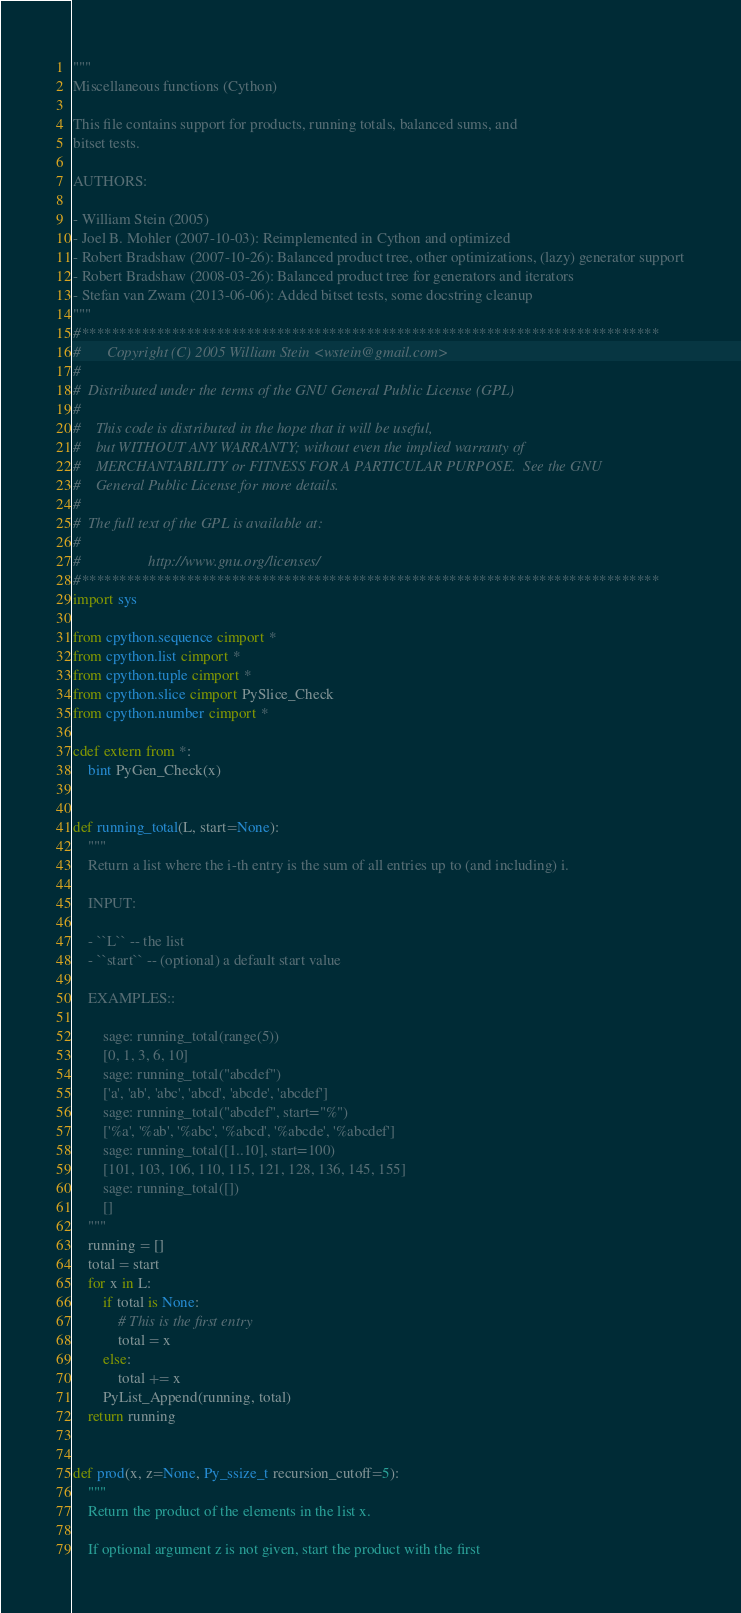Convert code to text. <code><loc_0><loc_0><loc_500><loc_500><_Cython_>"""
Miscellaneous functions (Cython)

This file contains support for products, running totals, balanced sums, and
bitset tests.

AUTHORS:

- William Stein (2005)
- Joel B. Mohler (2007-10-03): Reimplemented in Cython and optimized
- Robert Bradshaw (2007-10-26): Balanced product tree, other optimizations, (lazy) generator support
- Robert Bradshaw (2008-03-26): Balanced product tree for generators and iterators
- Stefan van Zwam (2013-06-06): Added bitset tests, some docstring cleanup
"""
#*****************************************************************************
#       Copyright (C) 2005 William Stein <wstein@gmail.com>
#
#  Distributed under the terms of the GNU General Public License (GPL)
#
#    This code is distributed in the hope that it will be useful,
#    but WITHOUT ANY WARRANTY; without even the implied warranty of
#    MERCHANTABILITY or FITNESS FOR A PARTICULAR PURPOSE.  See the GNU
#    General Public License for more details.
#
#  The full text of the GPL is available at:
#
#                  http://www.gnu.org/licenses/
#*****************************************************************************
import sys

from cpython.sequence cimport *
from cpython.list cimport *
from cpython.tuple cimport *
from cpython.slice cimport PySlice_Check
from cpython.number cimport *

cdef extern from *:
    bint PyGen_Check(x)


def running_total(L, start=None):
    """
    Return a list where the i-th entry is the sum of all entries up to (and including) i.

    INPUT:

    - ``L`` -- the list
    - ``start`` -- (optional) a default start value

    EXAMPLES::

        sage: running_total(range(5))
        [0, 1, 3, 6, 10]
        sage: running_total("abcdef")
        ['a', 'ab', 'abc', 'abcd', 'abcde', 'abcdef']
        sage: running_total("abcdef", start="%")
        ['%a', '%ab', '%abc', '%abcd', '%abcde', '%abcdef']
        sage: running_total([1..10], start=100)
        [101, 103, 106, 110, 115, 121, 128, 136, 145, 155]
        sage: running_total([])
        []
    """
    running = []
    total = start
    for x in L:
        if total is None:
            # This is the first entry
            total = x
        else:
            total += x
        PyList_Append(running, total)
    return running


def prod(x, z=None, Py_ssize_t recursion_cutoff=5):
    """
    Return the product of the elements in the list x.

    If optional argument z is not given, start the product with the first</code> 